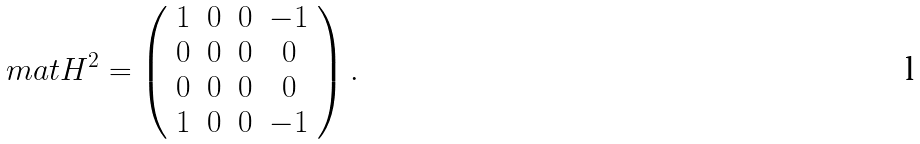<formula> <loc_0><loc_0><loc_500><loc_500>\ m a t H ^ { 2 } = \left ( \begin{array} { c c c c } 1 & 0 & 0 & - 1 \\ 0 & 0 & 0 & 0 \\ 0 & 0 & 0 & 0 \\ 1 & 0 & 0 & - 1 \end{array} \right ) .</formula> 